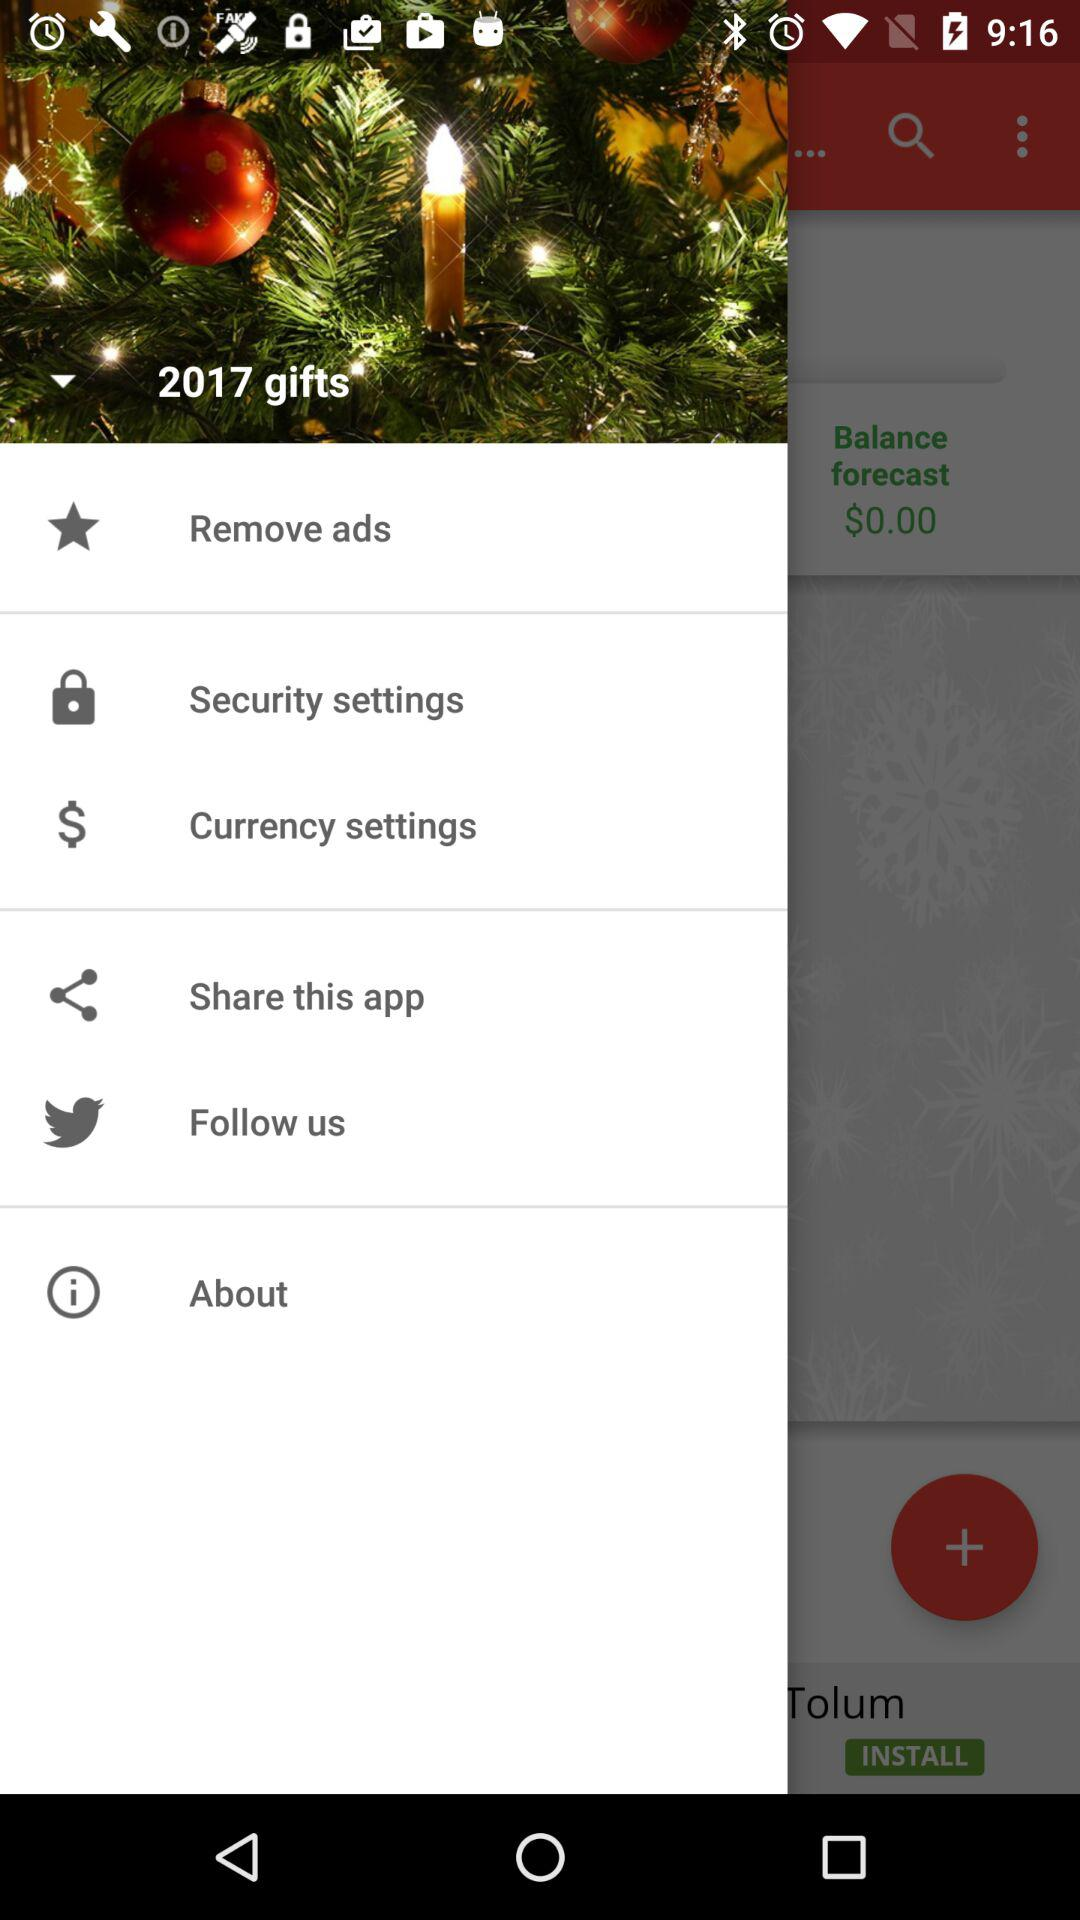How much is the balance forecast?
Answer the question using a single word or phrase. $0.00 